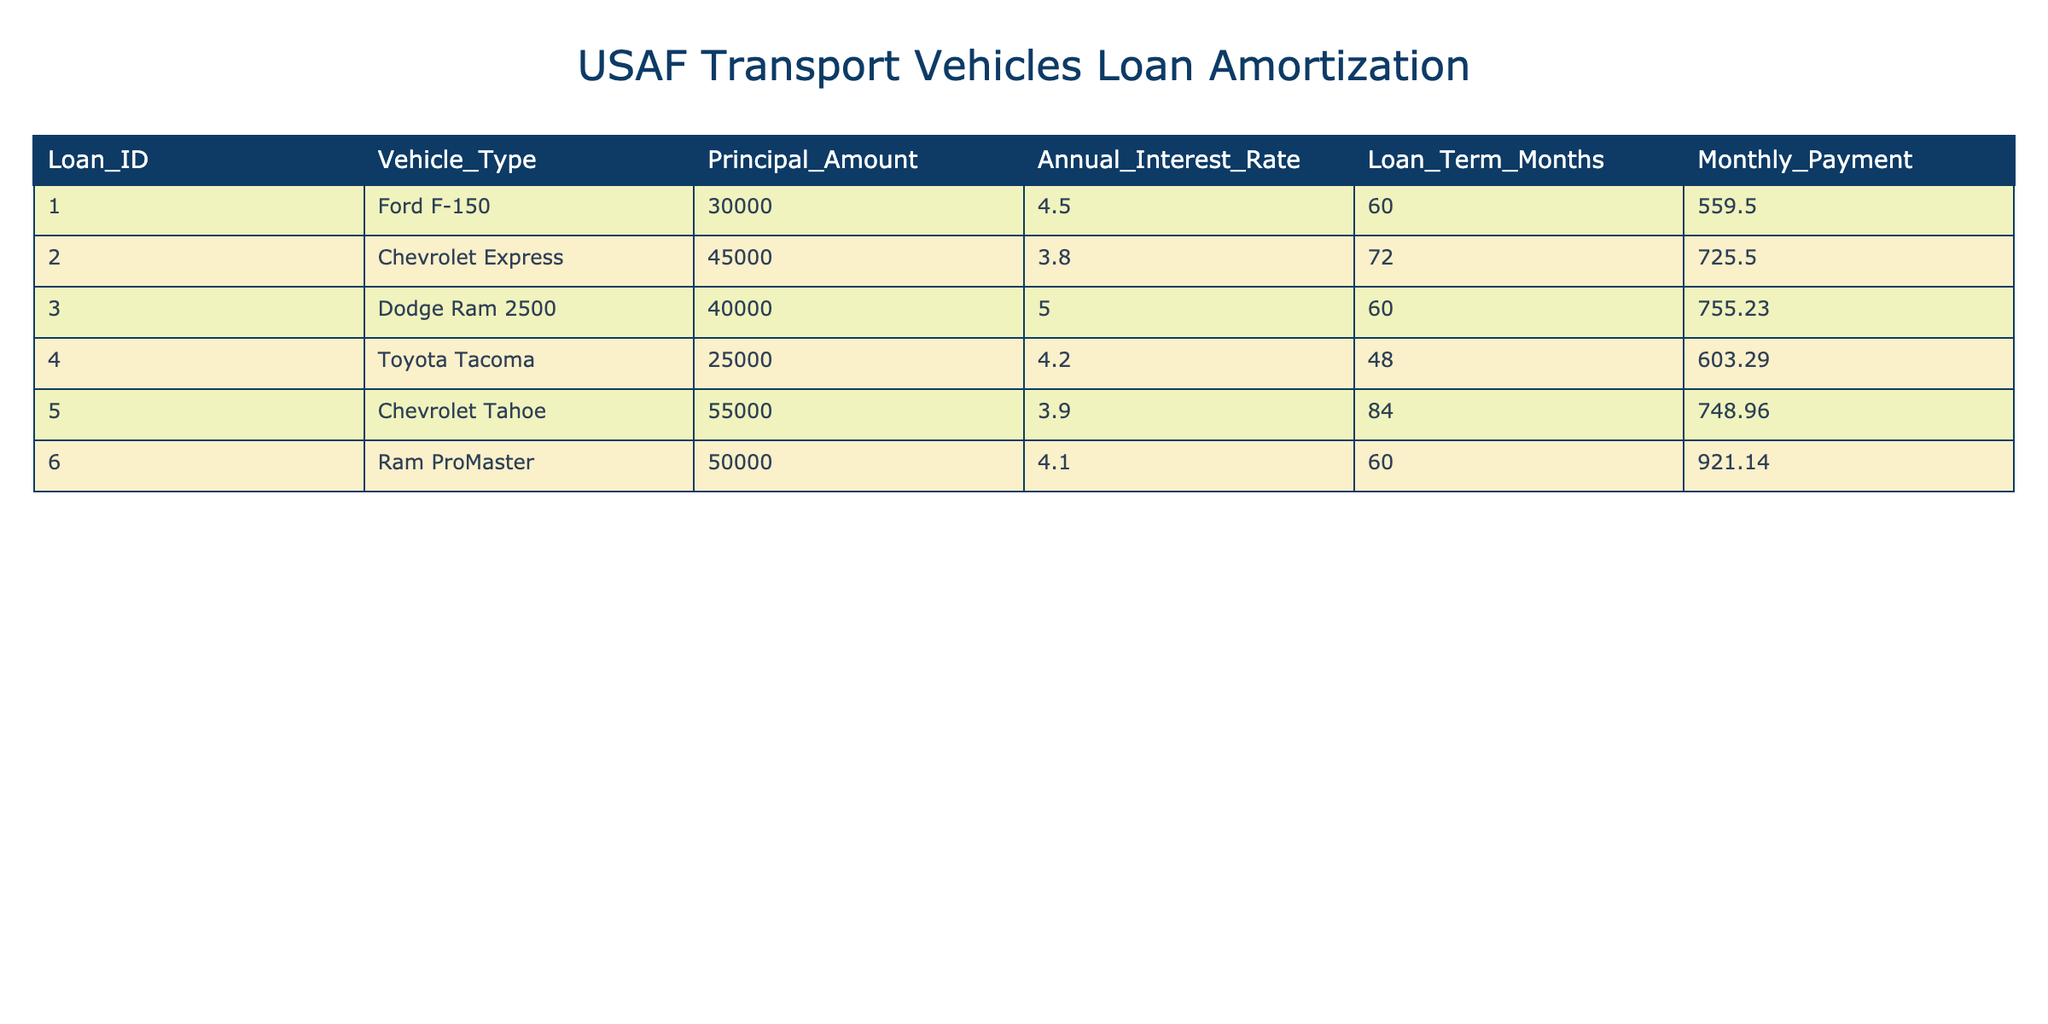What is the principal amount for the Chevrolet Express? In the table, I look for the row representing the Chevrolet Express. The column labeled "Principal Amount" shows the value of 45,000.
Answer: 45,000 What is the monthly payment for the Dodge Ram 2500? I check the Dodge Ram 2500 in the table and find the column labeled "Monthly Payment," which shows a value of 755.23.
Answer: 755.23 Which vehicle has the highest annual interest rate? By inspecting the annual interest rate column, I observe that the Dodge Ram 2500 has an interest rate of 5.0, which is greater than all other vehicles.
Answer: Dodge Ram 2500 What is the average monthly payment for all vehicles? I first sum the monthly payments: 559.50 + 725.50 + 755.23 + 603.29 + 748.96 + 921.14 = 4,393.62. Then, I divide by the number of vehicles, which is 6: 4,393.62 / 6 = 732.27.
Answer: 732.27 Is the loan term for the Toyota Tacoma shorter than 60 months? I check the loan term column for the Toyota Tacoma and see it has a loan term of 48 months, which is indeed shorter than 60 months.
Answer: Yes What is the total principal amount for all vehicles? I sum the principal amounts for each vehicle: 30000 + 45000 + 40000 + 25000 + 55000 + 50000 = 245000.
Answer: 245000 How many vehicles have a monthly payment greater than 700? I review the monthly payment column and find that the Chevrolet Express (725.50), Dodge Ram 2500 (755.23), Chevrolet Tahoe (748.96), and Ram ProMaster (921.14) have payments greater than 700. That totals to 4 vehicles.
Answer: 4 What is the difference in principal amount between the highest and lowest vehicles? The highest principal amount is for the Chevrolet Tahoe at 55,000, and the lowest is for the Toyota Tacoma at 25,000. The difference is 55,000 - 25,000 = 30,000.
Answer: 30,000 Which vehicle takes the longest to finance in months? I look at the loan term column and see that the Chevrolet Tahoe has the longest loan term of 84 months compared to all other vehicles.
Answer: Chevrolet Tahoe 